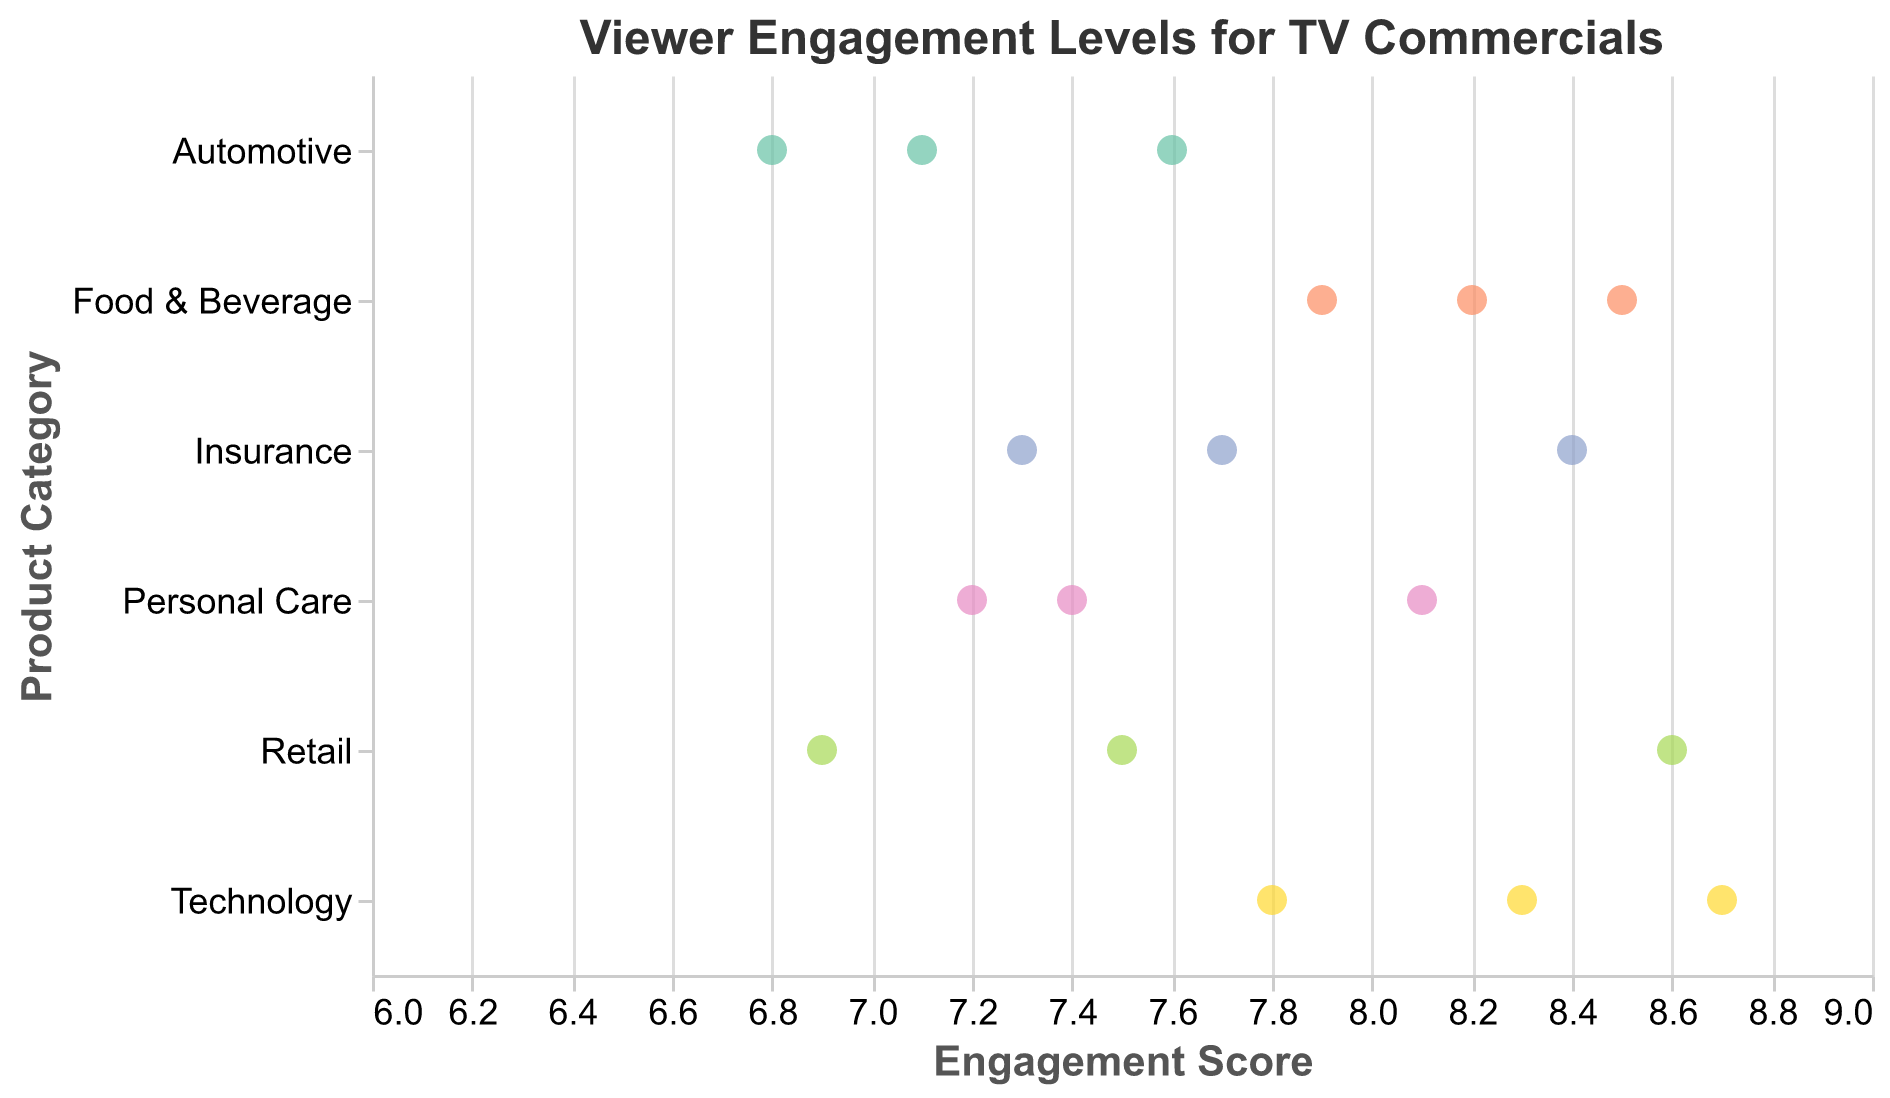What is the highest engagement score for the Technology category? The highest engagement score in the Technology category can be found by looking at the data points in the plot associated with Technology and noting the maximum score. The brands in the Technology category are Apple (8.7), Samsung (8.3), and Microsoft (7.8). The highest score among these is 8.7.
Answer: 8.7 Which brand in the Food & Beverage category has the highest engagement score? To find the brand with the highest engagement score in the Food & Beverage category, look at the data points for Coca-Cola (8.2), Pepsi (7.9), and Doritos (8.5). The highest score among them is 8.5, which belongs to Doritos.
Answer: Doritos What is the average engagement score for the Automotive category? Sum the engagement scores of the Automotive category brands and divide by the total number of brands. The brands are Toyota (6.8), Ford (7.1), and BMW (7.6). The sum is 6.8 + 7.1 + 7.6 = 21.5. There are 3 brands, so the average is 21.5 / 3 = 7.17.
Answer: 7.17 Which category has the least variability in engagement scores? Variety can be judged by the spread of data points within each category on the plot. Personal Care has brands with scores of 7.4, 8.1, and 7.2, giving a range of 8.1 - 7.2 = 0.9. This range is relatively small compared to other categories, indicating low variability.
Answer: Personal Care Is there a Retail brand that has a higher engagement score than all the Insurance brands? First, identify the highest engagement score among Insurance brands, which is 8.4 for Geico. Then, look at the Retail brands and check if any score above 8.4 is there. Amazon in the Retail category has a score of 8.6, which is higher than 8.4.
Answer: Yes, Amazon What is the difference between the highest and lowest engagement scores across all categories? First, identify the highest and lowest engagement scores from all data points. The highest is 8.7 by Apple (Technology), and the lowest is 6.8 by Toyota (Automotive). The difference is 8.7 - 6.8 = 1.9.
Answer: 1.9 How many brands in total have an engagement score above 8? Count the number of data points where the engagement score is greater than 8. The brands are Coca-Cola (8.2), Doritos (8.5), Apple (8.7), Samsung (8.3), Old Spice (8.1), Geico (8.4), and Amazon (8.6). There are 7 such brands.
Answer: 7 Comparing Technology and Retail categories, which has higher average engagement scores? Calculate the average score for each category. Technology scores: Apple (8.7), Samsung (8.3), Microsoft (7.8). Average = (8.7 + 8.3 + 7.8) / 3 = 8.27. Retail scores: Amazon (8.6), Walmart (6.9), Target (7.5). Average = (8.6 + 6.9 + 7.5) / 3 = 7.67. Technology category has higher average engagement scores.
Answer: Technology Which brand in the Insurance category has the lowest engagement score? Within the Insurance category, look at the data points for Geico (8.4), Progressive (7.7), and State Farm (7.3). The lowest score among these is 7.3, which belongs to State Farm.
Answer: State Farm Is there any category where all brands have engagement scores above 7? Check all data points within each category. Upon reviewing, Food & Beverage (Coca-Cola 8.2, Pepsi 7.9, Doritos 8.5), Technology (Apple 8.7, Samsung 8.3, Microsoft 7.8), and Insurance (Geico 8.4, Progressive 7.7, State Farm 7.3) all have scores above 7 for all brands.
Answer: Yes, Food & Beverage, Technology, and Insurance 